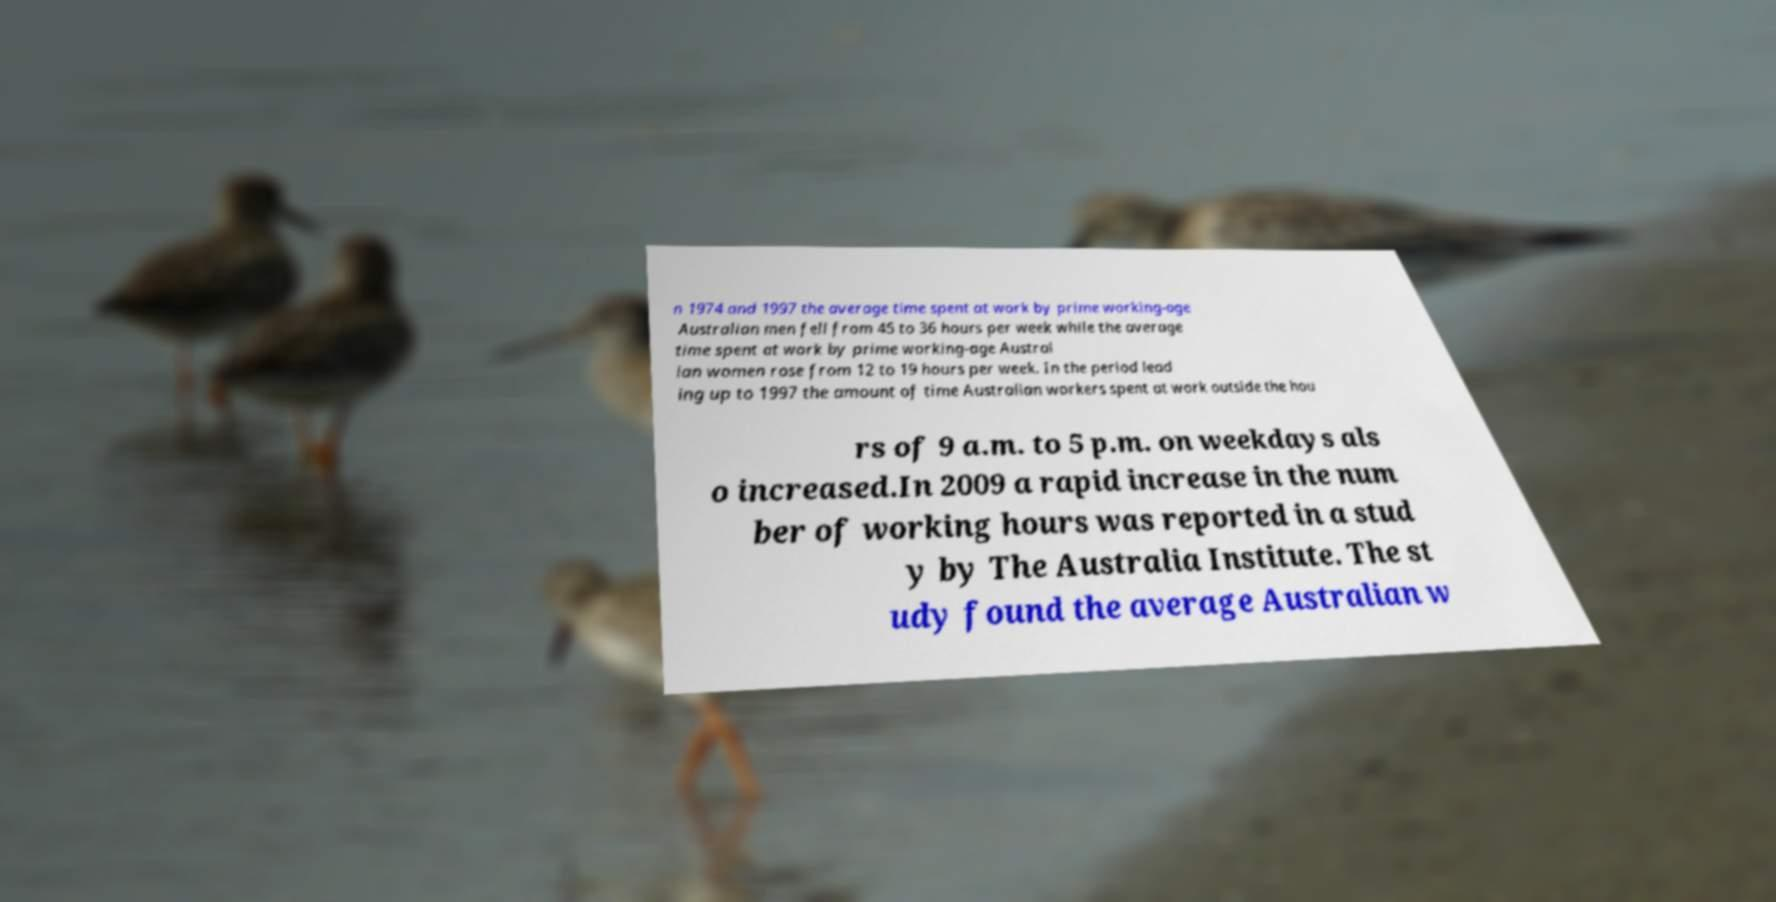Can you read and provide the text displayed in the image?This photo seems to have some interesting text. Can you extract and type it out for me? n 1974 and 1997 the average time spent at work by prime working-age Australian men fell from 45 to 36 hours per week while the average time spent at work by prime working-age Austral ian women rose from 12 to 19 hours per week. In the period lead ing up to 1997 the amount of time Australian workers spent at work outside the hou rs of 9 a.m. to 5 p.m. on weekdays als o increased.In 2009 a rapid increase in the num ber of working hours was reported in a stud y by The Australia Institute. The st udy found the average Australian w 